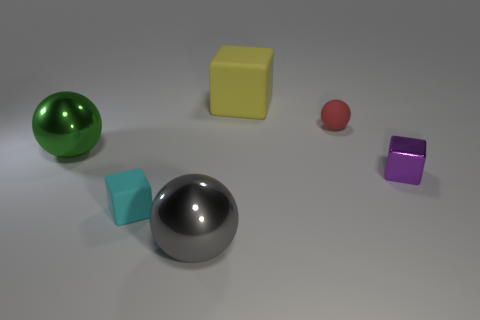Can you tell me the number of spherical objects in the image? Certainly! There are two spherical objects in the image: one large green ball with a shiny surface, possibly a treated plastic or glass, and a smaller red ball that looks matte, potentially rubber or a textured plastic. 